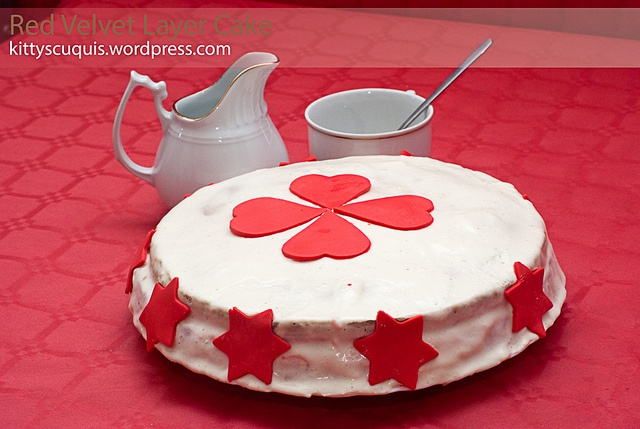Describe the objects in this image and their specific colors. I can see cake in black, white, brown, and salmon tones, cup in black, darkgray, gray, and lightgray tones, and spoon in black, darkgray, gray, and lightgray tones in this image. 